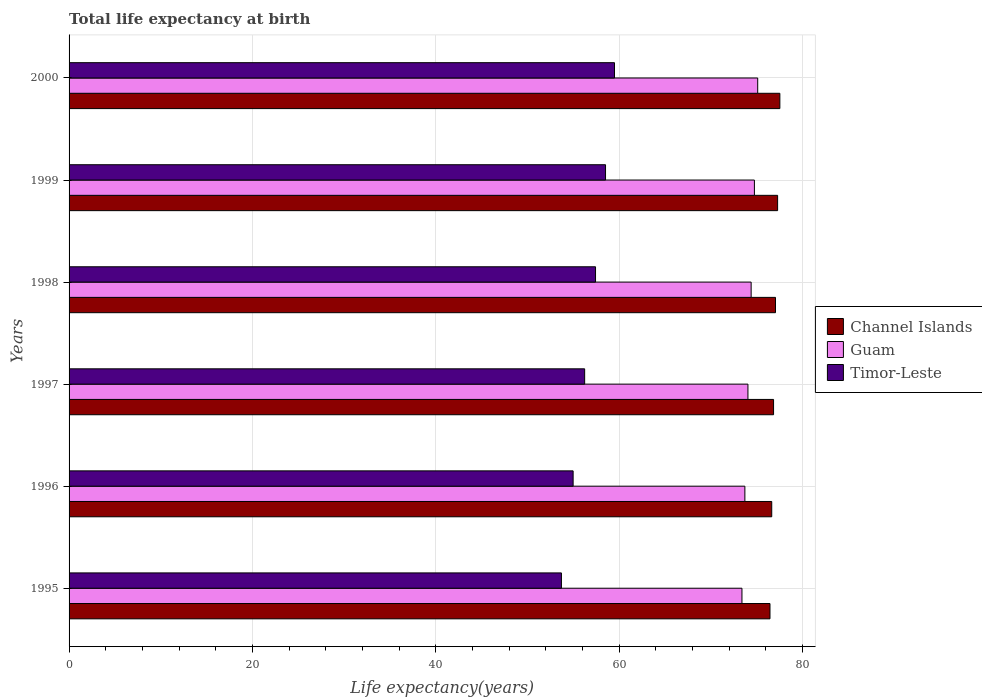How many different coloured bars are there?
Your answer should be compact. 3. How many groups of bars are there?
Provide a short and direct response. 6. What is the label of the 3rd group of bars from the top?
Give a very brief answer. 1998. In how many cases, is the number of bars for a given year not equal to the number of legend labels?
Provide a short and direct response. 0. What is the life expectancy at birth in in Guam in 1998?
Keep it short and to the point. 74.38. Across all years, what is the maximum life expectancy at birth in in Guam?
Ensure brevity in your answer.  75.1. Across all years, what is the minimum life expectancy at birth in in Channel Islands?
Your answer should be compact. 76.44. In which year was the life expectancy at birth in in Channel Islands maximum?
Keep it short and to the point. 2000. In which year was the life expectancy at birth in in Guam minimum?
Provide a short and direct response. 1995. What is the total life expectancy at birth in in Timor-Leste in the graph?
Your answer should be compact. 340.29. What is the difference between the life expectancy at birth in in Guam in 1995 and that in 1996?
Provide a short and direct response. -0.32. What is the difference between the life expectancy at birth in in Guam in 1995 and the life expectancy at birth in in Channel Islands in 1999?
Provide a short and direct response. -3.89. What is the average life expectancy at birth in in Channel Islands per year?
Provide a short and direct response. 76.95. In the year 2000, what is the difference between the life expectancy at birth in in Guam and life expectancy at birth in in Timor-Leste?
Your answer should be compact. 15.62. In how many years, is the life expectancy at birth in in Guam greater than 4 years?
Your answer should be very brief. 6. What is the ratio of the life expectancy at birth in in Channel Islands in 1996 to that in 1999?
Give a very brief answer. 0.99. Is the life expectancy at birth in in Timor-Leste in 1998 less than that in 1999?
Your answer should be compact. Yes. Is the difference between the life expectancy at birth in in Guam in 1995 and 1996 greater than the difference between the life expectancy at birth in in Timor-Leste in 1995 and 1996?
Provide a succinct answer. Yes. What is the difference between the highest and the second highest life expectancy at birth in in Guam?
Offer a very short reply. 0.36. What is the difference between the highest and the lowest life expectancy at birth in in Channel Islands?
Provide a succinct answer. 1.08. What does the 3rd bar from the top in 1996 represents?
Your answer should be very brief. Channel Islands. What does the 2nd bar from the bottom in 1999 represents?
Your answer should be very brief. Guam. Is it the case that in every year, the sum of the life expectancy at birth in in Timor-Leste and life expectancy at birth in in Channel Islands is greater than the life expectancy at birth in in Guam?
Offer a terse response. Yes. Are all the bars in the graph horizontal?
Ensure brevity in your answer.  Yes. Are the values on the major ticks of X-axis written in scientific E-notation?
Offer a terse response. No. Does the graph contain any zero values?
Your response must be concise. No. How many legend labels are there?
Offer a terse response. 3. How are the legend labels stacked?
Keep it short and to the point. Vertical. What is the title of the graph?
Give a very brief answer. Total life expectancy at birth. Does "Congo (Democratic)" appear as one of the legend labels in the graph?
Your answer should be very brief. No. What is the label or title of the X-axis?
Your answer should be compact. Life expectancy(years). What is the label or title of the Y-axis?
Provide a short and direct response. Years. What is the Life expectancy(years) of Channel Islands in 1995?
Your answer should be very brief. 76.44. What is the Life expectancy(years) of Guam in 1995?
Offer a very short reply. 73.38. What is the Life expectancy(years) of Timor-Leste in 1995?
Offer a very short reply. 53.7. What is the Life expectancy(years) in Channel Islands in 1996?
Provide a short and direct response. 76.63. What is the Life expectancy(years) of Guam in 1996?
Keep it short and to the point. 73.7. What is the Life expectancy(years) of Timor-Leste in 1996?
Your answer should be compact. 54.97. What is the Life expectancy(years) in Channel Islands in 1997?
Your answer should be very brief. 76.83. What is the Life expectancy(years) of Guam in 1997?
Your response must be concise. 74.03. What is the Life expectancy(years) of Timor-Leste in 1997?
Give a very brief answer. 56.23. What is the Life expectancy(years) of Channel Islands in 1998?
Offer a terse response. 77.04. What is the Life expectancy(years) of Guam in 1998?
Your response must be concise. 74.38. What is the Life expectancy(years) in Timor-Leste in 1998?
Give a very brief answer. 57.41. What is the Life expectancy(years) of Channel Islands in 1999?
Provide a succinct answer. 77.27. What is the Life expectancy(years) of Guam in 1999?
Ensure brevity in your answer.  74.74. What is the Life expectancy(years) in Timor-Leste in 1999?
Offer a terse response. 58.5. What is the Life expectancy(years) in Channel Islands in 2000?
Your response must be concise. 77.51. What is the Life expectancy(years) of Guam in 2000?
Give a very brief answer. 75.1. What is the Life expectancy(years) in Timor-Leste in 2000?
Give a very brief answer. 59.48. Across all years, what is the maximum Life expectancy(years) in Channel Islands?
Provide a succinct answer. 77.51. Across all years, what is the maximum Life expectancy(years) of Guam?
Provide a succinct answer. 75.1. Across all years, what is the maximum Life expectancy(years) of Timor-Leste?
Your response must be concise. 59.48. Across all years, what is the minimum Life expectancy(years) in Channel Islands?
Provide a short and direct response. 76.44. Across all years, what is the minimum Life expectancy(years) of Guam?
Make the answer very short. 73.38. Across all years, what is the minimum Life expectancy(years) in Timor-Leste?
Provide a short and direct response. 53.7. What is the total Life expectancy(years) in Channel Islands in the graph?
Make the answer very short. 461.71. What is the total Life expectancy(years) of Guam in the graph?
Keep it short and to the point. 445.33. What is the total Life expectancy(years) in Timor-Leste in the graph?
Provide a succinct answer. 340.29. What is the difference between the Life expectancy(years) of Channel Islands in 1995 and that in 1996?
Offer a very short reply. -0.19. What is the difference between the Life expectancy(years) of Guam in 1995 and that in 1996?
Your response must be concise. -0.32. What is the difference between the Life expectancy(years) in Timor-Leste in 1995 and that in 1996?
Your response must be concise. -1.27. What is the difference between the Life expectancy(years) in Channel Islands in 1995 and that in 1997?
Your answer should be compact. -0.39. What is the difference between the Life expectancy(years) in Guam in 1995 and that in 1997?
Give a very brief answer. -0.65. What is the difference between the Life expectancy(years) in Timor-Leste in 1995 and that in 1997?
Provide a succinct answer. -2.53. What is the difference between the Life expectancy(years) in Channel Islands in 1995 and that in 1998?
Your answer should be very brief. -0.6. What is the difference between the Life expectancy(years) in Guam in 1995 and that in 1998?
Your answer should be very brief. -1. What is the difference between the Life expectancy(years) in Timor-Leste in 1995 and that in 1998?
Your answer should be very brief. -3.72. What is the difference between the Life expectancy(years) of Channel Islands in 1995 and that in 1999?
Keep it short and to the point. -0.83. What is the difference between the Life expectancy(years) in Guam in 1995 and that in 1999?
Your answer should be compact. -1.36. What is the difference between the Life expectancy(years) of Timor-Leste in 1995 and that in 1999?
Make the answer very short. -4.81. What is the difference between the Life expectancy(years) of Channel Islands in 1995 and that in 2000?
Keep it short and to the point. -1.08. What is the difference between the Life expectancy(years) in Guam in 1995 and that in 2000?
Offer a terse response. -1.72. What is the difference between the Life expectancy(years) of Timor-Leste in 1995 and that in 2000?
Offer a terse response. -5.79. What is the difference between the Life expectancy(years) of Channel Islands in 1996 and that in 1997?
Make the answer very short. -0.2. What is the difference between the Life expectancy(years) in Guam in 1996 and that in 1997?
Your response must be concise. -0.33. What is the difference between the Life expectancy(years) in Timor-Leste in 1996 and that in 1997?
Offer a very short reply. -1.26. What is the difference between the Life expectancy(years) of Channel Islands in 1996 and that in 1998?
Keep it short and to the point. -0.41. What is the difference between the Life expectancy(years) of Guam in 1996 and that in 1998?
Provide a succinct answer. -0.68. What is the difference between the Life expectancy(years) of Timor-Leste in 1996 and that in 1998?
Provide a succinct answer. -2.44. What is the difference between the Life expectancy(years) in Channel Islands in 1996 and that in 1999?
Offer a very short reply. -0.64. What is the difference between the Life expectancy(years) in Guam in 1996 and that in 1999?
Your answer should be compact. -1.04. What is the difference between the Life expectancy(years) in Timor-Leste in 1996 and that in 1999?
Provide a short and direct response. -3.53. What is the difference between the Life expectancy(years) in Channel Islands in 1996 and that in 2000?
Give a very brief answer. -0.89. What is the difference between the Life expectancy(years) in Guam in 1996 and that in 2000?
Make the answer very short. -1.4. What is the difference between the Life expectancy(years) in Timor-Leste in 1996 and that in 2000?
Keep it short and to the point. -4.51. What is the difference between the Life expectancy(years) in Channel Islands in 1997 and that in 1998?
Your answer should be very brief. -0.21. What is the difference between the Life expectancy(years) in Guam in 1997 and that in 1998?
Offer a very short reply. -0.35. What is the difference between the Life expectancy(years) in Timor-Leste in 1997 and that in 1998?
Your answer should be very brief. -1.19. What is the difference between the Life expectancy(years) in Channel Islands in 1997 and that in 1999?
Make the answer very short. -0.44. What is the difference between the Life expectancy(years) of Guam in 1997 and that in 1999?
Provide a short and direct response. -0.7. What is the difference between the Life expectancy(years) in Timor-Leste in 1997 and that in 1999?
Your response must be concise. -2.28. What is the difference between the Life expectancy(years) in Channel Islands in 1997 and that in 2000?
Give a very brief answer. -0.69. What is the difference between the Life expectancy(years) in Guam in 1997 and that in 2000?
Your answer should be compact. -1.06. What is the difference between the Life expectancy(years) of Timor-Leste in 1997 and that in 2000?
Ensure brevity in your answer.  -3.25. What is the difference between the Life expectancy(years) of Channel Islands in 1998 and that in 1999?
Make the answer very short. -0.23. What is the difference between the Life expectancy(years) of Guam in 1998 and that in 1999?
Keep it short and to the point. -0.36. What is the difference between the Life expectancy(years) of Timor-Leste in 1998 and that in 1999?
Keep it short and to the point. -1.09. What is the difference between the Life expectancy(years) of Channel Islands in 1998 and that in 2000?
Keep it short and to the point. -0.47. What is the difference between the Life expectancy(years) in Guam in 1998 and that in 2000?
Provide a succinct answer. -0.72. What is the difference between the Life expectancy(years) in Timor-Leste in 1998 and that in 2000?
Ensure brevity in your answer.  -2.07. What is the difference between the Life expectancy(years) in Channel Islands in 1999 and that in 2000?
Make the answer very short. -0.25. What is the difference between the Life expectancy(years) in Guam in 1999 and that in 2000?
Keep it short and to the point. -0.36. What is the difference between the Life expectancy(years) of Timor-Leste in 1999 and that in 2000?
Ensure brevity in your answer.  -0.98. What is the difference between the Life expectancy(years) in Channel Islands in 1995 and the Life expectancy(years) in Guam in 1996?
Your answer should be very brief. 2.74. What is the difference between the Life expectancy(years) in Channel Islands in 1995 and the Life expectancy(years) in Timor-Leste in 1996?
Provide a succinct answer. 21.47. What is the difference between the Life expectancy(years) in Guam in 1995 and the Life expectancy(years) in Timor-Leste in 1996?
Your answer should be very brief. 18.41. What is the difference between the Life expectancy(years) of Channel Islands in 1995 and the Life expectancy(years) of Guam in 1997?
Offer a very short reply. 2.4. What is the difference between the Life expectancy(years) in Channel Islands in 1995 and the Life expectancy(years) in Timor-Leste in 1997?
Keep it short and to the point. 20.21. What is the difference between the Life expectancy(years) in Guam in 1995 and the Life expectancy(years) in Timor-Leste in 1997?
Provide a succinct answer. 17.15. What is the difference between the Life expectancy(years) of Channel Islands in 1995 and the Life expectancy(years) of Guam in 1998?
Offer a very short reply. 2.05. What is the difference between the Life expectancy(years) of Channel Islands in 1995 and the Life expectancy(years) of Timor-Leste in 1998?
Your answer should be very brief. 19.02. What is the difference between the Life expectancy(years) in Guam in 1995 and the Life expectancy(years) in Timor-Leste in 1998?
Keep it short and to the point. 15.97. What is the difference between the Life expectancy(years) in Channel Islands in 1995 and the Life expectancy(years) in Guam in 1999?
Provide a succinct answer. 1.7. What is the difference between the Life expectancy(years) of Channel Islands in 1995 and the Life expectancy(years) of Timor-Leste in 1999?
Provide a succinct answer. 17.93. What is the difference between the Life expectancy(years) of Guam in 1995 and the Life expectancy(years) of Timor-Leste in 1999?
Provide a succinct answer. 14.88. What is the difference between the Life expectancy(years) of Channel Islands in 1995 and the Life expectancy(years) of Guam in 2000?
Your answer should be very brief. 1.34. What is the difference between the Life expectancy(years) in Channel Islands in 1995 and the Life expectancy(years) in Timor-Leste in 2000?
Make the answer very short. 16.96. What is the difference between the Life expectancy(years) in Guam in 1995 and the Life expectancy(years) in Timor-Leste in 2000?
Give a very brief answer. 13.9. What is the difference between the Life expectancy(years) of Channel Islands in 1996 and the Life expectancy(years) of Guam in 1997?
Your answer should be compact. 2.59. What is the difference between the Life expectancy(years) of Channel Islands in 1996 and the Life expectancy(years) of Timor-Leste in 1997?
Your answer should be very brief. 20.4. What is the difference between the Life expectancy(years) of Guam in 1996 and the Life expectancy(years) of Timor-Leste in 1997?
Give a very brief answer. 17.47. What is the difference between the Life expectancy(years) in Channel Islands in 1996 and the Life expectancy(years) in Guam in 1998?
Provide a short and direct response. 2.25. What is the difference between the Life expectancy(years) in Channel Islands in 1996 and the Life expectancy(years) in Timor-Leste in 1998?
Make the answer very short. 19.22. What is the difference between the Life expectancy(years) of Guam in 1996 and the Life expectancy(years) of Timor-Leste in 1998?
Make the answer very short. 16.29. What is the difference between the Life expectancy(years) in Channel Islands in 1996 and the Life expectancy(years) in Guam in 1999?
Offer a very short reply. 1.89. What is the difference between the Life expectancy(years) in Channel Islands in 1996 and the Life expectancy(years) in Timor-Leste in 1999?
Provide a short and direct response. 18.12. What is the difference between the Life expectancy(years) of Guam in 1996 and the Life expectancy(years) of Timor-Leste in 1999?
Give a very brief answer. 15.2. What is the difference between the Life expectancy(years) in Channel Islands in 1996 and the Life expectancy(years) in Guam in 2000?
Ensure brevity in your answer.  1.53. What is the difference between the Life expectancy(years) of Channel Islands in 1996 and the Life expectancy(years) of Timor-Leste in 2000?
Provide a short and direct response. 17.15. What is the difference between the Life expectancy(years) in Guam in 1996 and the Life expectancy(years) in Timor-Leste in 2000?
Make the answer very short. 14.22. What is the difference between the Life expectancy(years) of Channel Islands in 1997 and the Life expectancy(years) of Guam in 1998?
Keep it short and to the point. 2.44. What is the difference between the Life expectancy(years) in Channel Islands in 1997 and the Life expectancy(years) in Timor-Leste in 1998?
Provide a succinct answer. 19.41. What is the difference between the Life expectancy(years) of Guam in 1997 and the Life expectancy(years) of Timor-Leste in 1998?
Provide a succinct answer. 16.62. What is the difference between the Life expectancy(years) in Channel Islands in 1997 and the Life expectancy(years) in Guam in 1999?
Your answer should be compact. 2.09. What is the difference between the Life expectancy(years) of Channel Islands in 1997 and the Life expectancy(years) of Timor-Leste in 1999?
Your answer should be compact. 18.32. What is the difference between the Life expectancy(years) in Guam in 1997 and the Life expectancy(years) in Timor-Leste in 1999?
Ensure brevity in your answer.  15.53. What is the difference between the Life expectancy(years) of Channel Islands in 1997 and the Life expectancy(years) of Guam in 2000?
Provide a short and direct response. 1.73. What is the difference between the Life expectancy(years) of Channel Islands in 1997 and the Life expectancy(years) of Timor-Leste in 2000?
Ensure brevity in your answer.  17.35. What is the difference between the Life expectancy(years) of Guam in 1997 and the Life expectancy(years) of Timor-Leste in 2000?
Give a very brief answer. 14.55. What is the difference between the Life expectancy(years) of Channel Islands in 1998 and the Life expectancy(years) of Guam in 1999?
Your response must be concise. 2.3. What is the difference between the Life expectancy(years) of Channel Islands in 1998 and the Life expectancy(years) of Timor-Leste in 1999?
Your answer should be very brief. 18.54. What is the difference between the Life expectancy(years) in Guam in 1998 and the Life expectancy(years) in Timor-Leste in 1999?
Ensure brevity in your answer.  15.88. What is the difference between the Life expectancy(years) of Channel Islands in 1998 and the Life expectancy(years) of Guam in 2000?
Your answer should be very brief. 1.94. What is the difference between the Life expectancy(years) in Channel Islands in 1998 and the Life expectancy(years) in Timor-Leste in 2000?
Provide a short and direct response. 17.56. What is the difference between the Life expectancy(years) of Guam in 1998 and the Life expectancy(years) of Timor-Leste in 2000?
Offer a very short reply. 14.9. What is the difference between the Life expectancy(years) of Channel Islands in 1999 and the Life expectancy(years) of Guam in 2000?
Offer a terse response. 2.17. What is the difference between the Life expectancy(years) in Channel Islands in 1999 and the Life expectancy(years) in Timor-Leste in 2000?
Your answer should be compact. 17.79. What is the difference between the Life expectancy(years) of Guam in 1999 and the Life expectancy(years) of Timor-Leste in 2000?
Your response must be concise. 15.26. What is the average Life expectancy(years) of Channel Islands per year?
Provide a succinct answer. 76.95. What is the average Life expectancy(years) of Guam per year?
Offer a terse response. 74.22. What is the average Life expectancy(years) in Timor-Leste per year?
Your response must be concise. 56.71. In the year 1995, what is the difference between the Life expectancy(years) in Channel Islands and Life expectancy(years) in Guam?
Ensure brevity in your answer.  3.06. In the year 1995, what is the difference between the Life expectancy(years) of Channel Islands and Life expectancy(years) of Timor-Leste?
Keep it short and to the point. 22.74. In the year 1995, what is the difference between the Life expectancy(years) of Guam and Life expectancy(years) of Timor-Leste?
Your answer should be compact. 19.69. In the year 1996, what is the difference between the Life expectancy(years) of Channel Islands and Life expectancy(years) of Guam?
Ensure brevity in your answer.  2.93. In the year 1996, what is the difference between the Life expectancy(years) of Channel Islands and Life expectancy(years) of Timor-Leste?
Keep it short and to the point. 21.66. In the year 1996, what is the difference between the Life expectancy(years) in Guam and Life expectancy(years) in Timor-Leste?
Make the answer very short. 18.73. In the year 1997, what is the difference between the Life expectancy(years) of Channel Islands and Life expectancy(years) of Guam?
Ensure brevity in your answer.  2.79. In the year 1997, what is the difference between the Life expectancy(years) in Channel Islands and Life expectancy(years) in Timor-Leste?
Your response must be concise. 20.6. In the year 1997, what is the difference between the Life expectancy(years) of Guam and Life expectancy(years) of Timor-Leste?
Your response must be concise. 17.81. In the year 1998, what is the difference between the Life expectancy(years) of Channel Islands and Life expectancy(years) of Guam?
Your answer should be very brief. 2.66. In the year 1998, what is the difference between the Life expectancy(years) in Channel Islands and Life expectancy(years) in Timor-Leste?
Provide a succinct answer. 19.63. In the year 1998, what is the difference between the Life expectancy(years) of Guam and Life expectancy(years) of Timor-Leste?
Offer a very short reply. 16.97. In the year 1999, what is the difference between the Life expectancy(years) in Channel Islands and Life expectancy(years) in Guam?
Give a very brief answer. 2.53. In the year 1999, what is the difference between the Life expectancy(years) in Channel Islands and Life expectancy(years) in Timor-Leste?
Give a very brief answer. 18.77. In the year 1999, what is the difference between the Life expectancy(years) in Guam and Life expectancy(years) in Timor-Leste?
Keep it short and to the point. 16.24. In the year 2000, what is the difference between the Life expectancy(years) of Channel Islands and Life expectancy(years) of Guam?
Make the answer very short. 2.42. In the year 2000, what is the difference between the Life expectancy(years) in Channel Islands and Life expectancy(years) in Timor-Leste?
Make the answer very short. 18.03. In the year 2000, what is the difference between the Life expectancy(years) in Guam and Life expectancy(years) in Timor-Leste?
Keep it short and to the point. 15.62. What is the ratio of the Life expectancy(years) in Channel Islands in 1995 to that in 1996?
Offer a terse response. 1. What is the ratio of the Life expectancy(years) of Guam in 1995 to that in 1996?
Offer a terse response. 1. What is the ratio of the Life expectancy(years) of Timor-Leste in 1995 to that in 1996?
Provide a short and direct response. 0.98. What is the ratio of the Life expectancy(years) of Channel Islands in 1995 to that in 1997?
Your answer should be compact. 0.99. What is the ratio of the Life expectancy(years) of Timor-Leste in 1995 to that in 1997?
Your answer should be very brief. 0.95. What is the ratio of the Life expectancy(years) in Guam in 1995 to that in 1998?
Your response must be concise. 0.99. What is the ratio of the Life expectancy(years) in Timor-Leste in 1995 to that in 1998?
Keep it short and to the point. 0.94. What is the ratio of the Life expectancy(years) of Channel Islands in 1995 to that in 1999?
Offer a terse response. 0.99. What is the ratio of the Life expectancy(years) in Guam in 1995 to that in 1999?
Give a very brief answer. 0.98. What is the ratio of the Life expectancy(years) of Timor-Leste in 1995 to that in 1999?
Make the answer very short. 0.92. What is the ratio of the Life expectancy(years) in Channel Islands in 1995 to that in 2000?
Your response must be concise. 0.99. What is the ratio of the Life expectancy(years) of Guam in 1995 to that in 2000?
Give a very brief answer. 0.98. What is the ratio of the Life expectancy(years) of Timor-Leste in 1995 to that in 2000?
Your answer should be compact. 0.9. What is the ratio of the Life expectancy(years) of Guam in 1996 to that in 1997?
Give a very brief answer. 1. What is the ratio of the Life expectancy(years) in Timor-Leste in 1996 to that in 1997?
Make the answer very short. 0.98. What is the ratio of the Life expectancy(years) in Channel Islands in 1996 to that in 1998?
Offer a terse response. 0.99. What is the ratio of the Life expectancy(years) in Guam in 1996 to that in 1998?
Make the answer very short. 0.99. What is the ratio of the Life expectancy(years) in Timor-Leste in 1996 to that in 1998?
Provide a succinct answer. 0.96. What is the ratio of the Life expectancy(years) of Channel Islands in 1996 to that in 1999?
Offer a very short reply. 0.99. What is the ratio of the Life expectancy(years) of Guam in 1996 to that in 1999?
Provide a succinct answer. 0.99. What is the ratio of the Life expectancy(years) in Timor-Leste in 1996 to that in 1999?
Your answer should be compact. 0.94. What is the ratio of the Life expectancy(years) of Guam in 1996 to that in 2000?
Provide a succinct answer. 0.98. What is the ratio of the Life expectancy(years) of Timor-Leste in 1996 to that in 2000?
Your answer should be very brief. 0.92. What is the ratio of the Life expectancy(years) in Channel Islands in 1997 to that in 1998?
Ensure brevity in your answer.  1. What is the ratio of the Life expectancy(years) of Timor-Leste in 1997 to that in 1998?
Your answer should be very brief. 0.98. What is the ratio of the Life expectancy(years) in Guam in 1997 to that in 1999?
Provide a short and direct response. 0.99. What is the ratio of the Life expectancy(years) in Timor-Leste in 1997 to that in 1999?
Provide a succinct answer. 0.96. What is the ratio of the Life expectancy(years) in Guam in 1997 to that in 2000?
Offer a terse response. 0.99. What is the ratio of the Life expectancy(years) in Timor-Leste in 1997 to that in 2000?
Ensure brevity in your answer.  0.95. What is the ratio of the Life expectancy(years) of Channel Islands in 1998 to that in 1999?
Offer a very short reply. 1. What is the ratio of the Life expectancy(years) of Guam in 1998 to that in 1999?
Your answer should be compact. 1. What is the ratio of the Life expectancy(years) of Timor-Leste in 1998 to that in 1999?
Your answer should be very brief. 0.98. What is the ratio of the Life expectancy(years) of Channel Islands in 1998 to that in 2000?
Ensure brevity in your answer.  0.99. What is the ratio of the Life expectancy(years) in Guam in 1998 to that in 2000?
Your answer should be compact. 0.99. What is the ratio of the Life expectancy(years) in Timor-Leste in 1998 to that in 2000?
Offer a terse response. 0.97. What is the ratio of the Life expectancy(years) in Channel Islands in 1999 to that in 2000?
Provide a short and direct response. 1. What is the ratio of the Life expectancy(years) of Guam in 1999 to that in 2000?
Make the answer very short. 1. What is the ratio of the Life expectancy(years) of Timor-Leste in 1999 to that in 2000?
Your response must be concise. 0.98. What is the difference between the highest and the second highest Life expectancy(years) of Channel Islands?
Offer a terse response. 0.25. What is the difference between the highest and the second highest Life expectancy(years) in Guam?
Provide a short and direct response. 0.36. What is the difference between the highest and the second highest Life expectancy(years) in Timor-Leste?
Give a very brief answer. 0.98. What is the difference between the highest and the lowest Life expectancy(years) in Channel Islands?
Offer a terse response. 1.08. What is the difference between the highest and the lowest Life expectancy(years) in Guam?
Offer a very short reply. 1.72. What is the difference between the highest and the lowest Life expectancy(years) of Timor-Leste?
Offer a terse response. 5.79. 